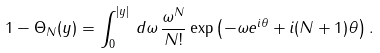<formula> <loc_0><loc_0><loc_500><loc_500>1 - \Theta _ { N } ( y ) = \int _ { 0 } ^ { | y | } \, d \omega \, \frac { \omega ^ { N } } { N ! } \exp \left ( - \omega e ^ { i \theta } + i ( N + 1 ) \theta \right ) .</formula> 